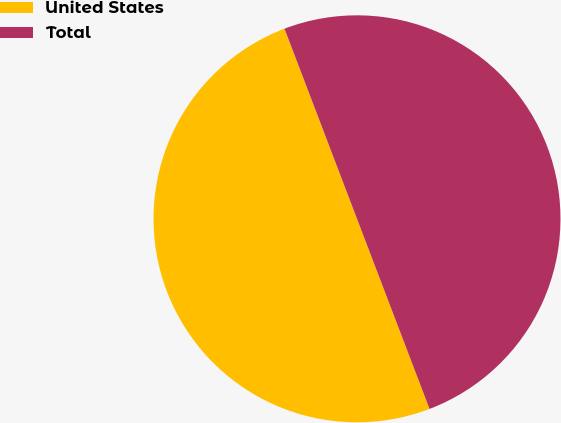Convert chart to OTSL. <chart><loc_0><loc_0><loc_500><loc_500><pie_chart><fcel>United States<fcel>Total<nl><fcel>50.0%<fcel>50.0%<nl></chart> 